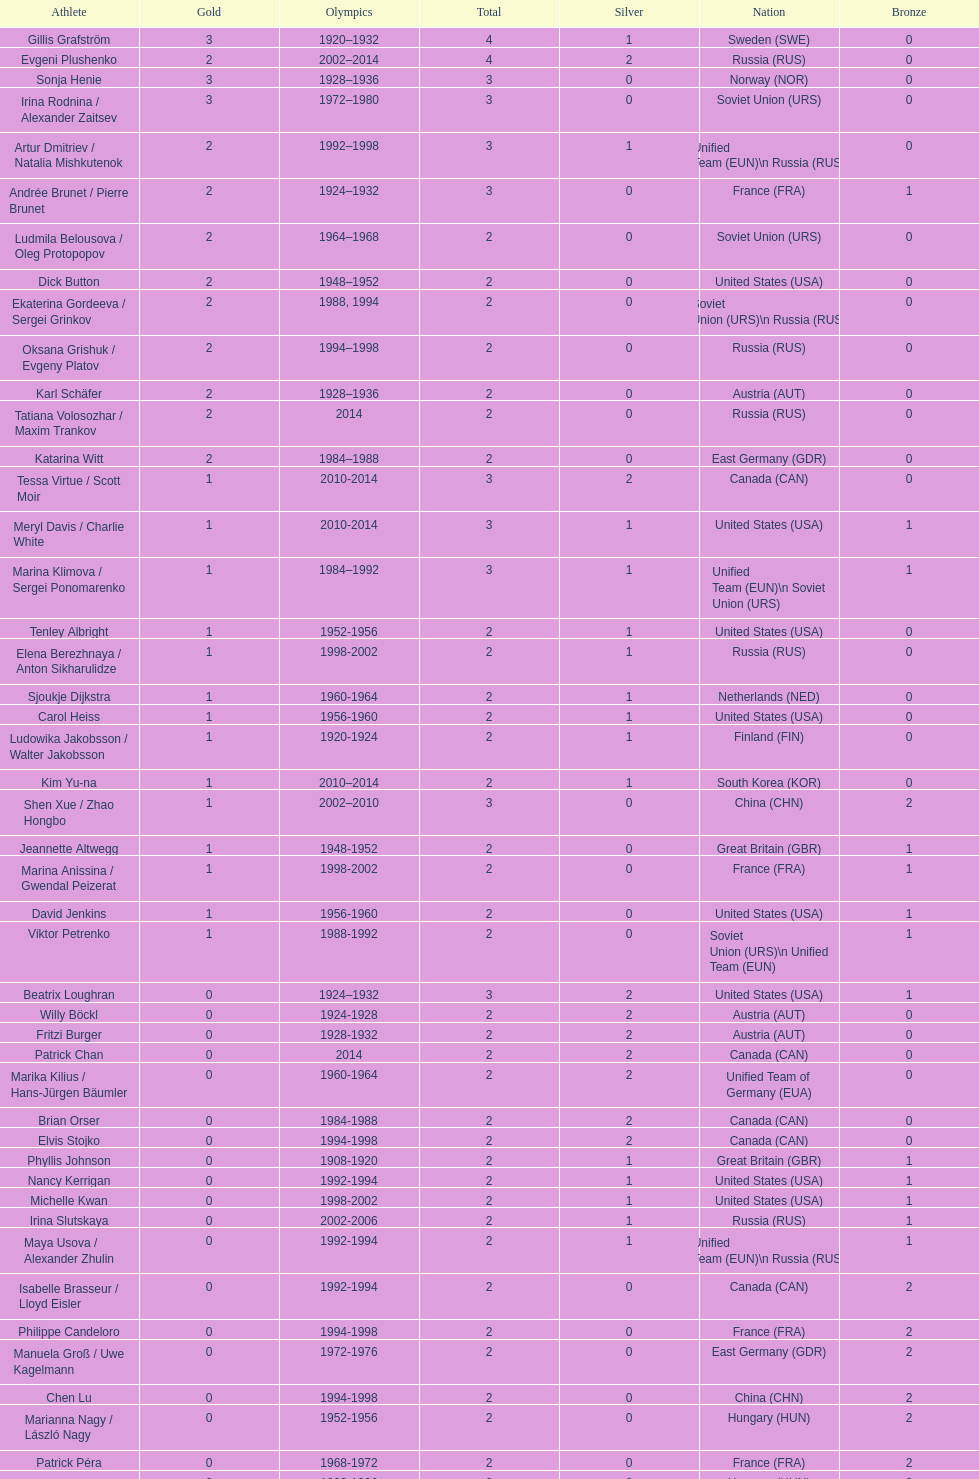How many total medals has the united states won in women's figure skating? 16. 